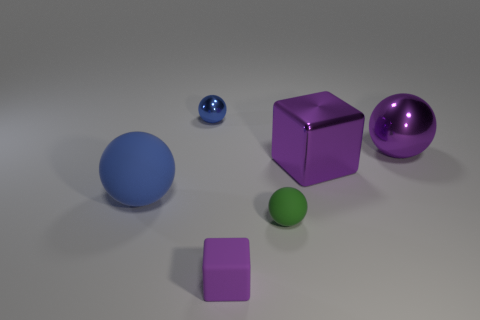There is a blue matte thing that is the same shape as the green matte thing; what is its size?
Keep it short and to the point. Large. There is a blue thing that is in front of the metallic sphere that is right of the small blue ball; what is its size?
Your answer should be very brief. Large. Are there the same number of blue shiny balls in front of the purple metallic ball and tiny yellow metallic cubes?
Ensure brevity in your answer.  Yes. How many other things are the same color as the tiny metallic thing?
Give a very brief answer. 1. Is the number of purple metallic blocks on the left side of the green rubber ball less than the number of tiny cyan things?
Your answer should be compact. No. Is there a green thing that has the same size as the blue metallic thing?
Make the answer very short. Yes. Do the shiny cube and the block that is in front of the big cube have the same color?
Keep it short and to the point. Yes. What number of big purple shiny blocks are to the right of the rubber object on the left side of the tiny purple matte cube?
Give a very brief answer. 1. What color is the big metallic object that is in front of the purple metal ball that is behind the metal cube?
Your answer should be compact. Purple. What is the material of the tiny thing that is in front of the big purple cube and behind the purple rubber thing?
Provide a short and direct response. Rubber. 